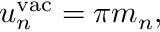Convert formula to latex. <formula><loc_0><loc_0><loc_500><loc_500>u _ { n } ^ { v a c } = \pi m _ { n } ,</formula> 